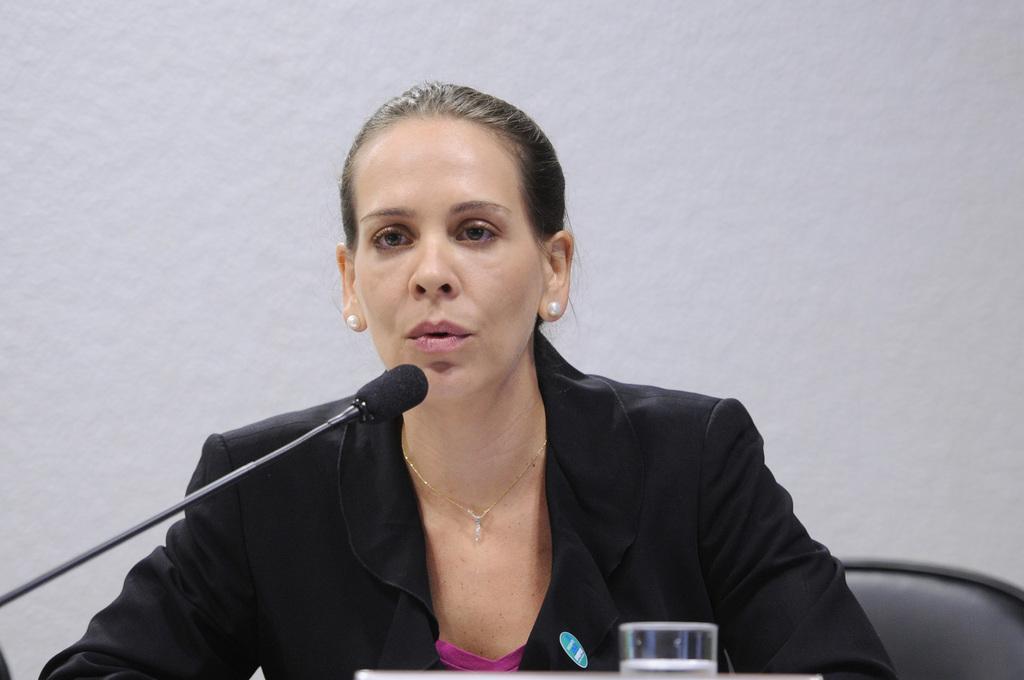How would you summarize this image in a sentence or two? In the picture I can see a woman wearing black color blazer, earrings and chain is sitting on the chair near the table where I can see a glass with water in it is kept on it. Here I can see a mic in front of her. In the background, I can see the wall. 